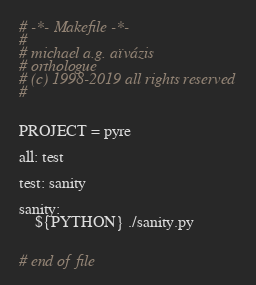Convert code to text. <code><loc_0><loc_0><loc_500><loc_500><_ObjectiveC_># -*- Makefile -*-
#
# michael a.g. aïvázis
# orthologue
# (c) 1998-2019 all rights reserved
#


PROJECT = pyre

all: test

test: sanity

sanity:
	${PYTHON} ./sanity.py


# end of file
</code> 